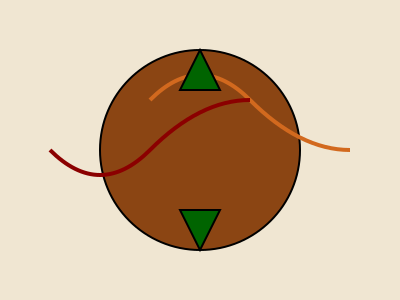Based on the Filipino tribal tattoo design shown above, which color combination and motif would be most effective in creating an immersive set design that authentically represents the Kalinga tribe's traditional tattoo art? To answer this question, we need to analyze the elements of the given Filipino tribal tattoo design and consider their significance in Kalinga culture:

1. Color palette:
   - Earth tones: Brown (#8b4513) and tan (#f0e6d2) represent connection to nature and land.
   - Dark red (#8b0000) symbolizes bravery and strength.
   - Dark green (#006400) represents the lush forests of the Cordillera region.

2. Motifs:
   - Circular shape: Represents unity and the cycle of life.
   - Curved lines: Symbolize rivers and mountains, important in Kalinga geography.
   - Triangular shapes: Often represent spearheads, symbolizing protection and warrior status.

3. Cultural significance:
   - Kalinga tattoos, known as "batok," are deeply rooted in their cultural identity.
   - Each element has a specific meaning related to social status, achievements, and spiritual beliefs.

4. Set design considerations:
   - Use of natural materials like bamboo and rattan to complement the earth tones.
   - Incorporating curved structures to mimic the flowing lines in the design.
   - Utilizing triangular elements in set pieces to echo the spearhead motifs.

5. Immersive experience:
   - Large-scale reproductions of tattoo patterns on walls or floors.
   - Lighting design using the color palette to create depth and atmosphere.
   - Interactive elements allowing audience members to explore the meanings behind different symbols.

The most effective combination would utilize all these elements, with a particular emphasis on the earth tones (brown and tan) for the primary set structure, accented with dark red and green. The curved and triangular motifs should be prominently featured in both the set's physical structure and in painted or projected designs.
Answer: Earth tones with red and green accents; curved lines and triangular motifs 